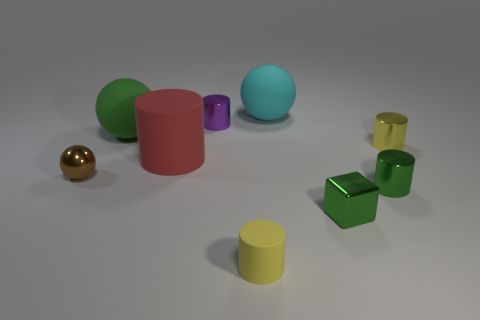Subtract all green spheres. How many spheres are left? 2 Subtract all purple cylinders. How many cylinders are left? 4 Add 6 green blocks. How many green blocks are left? 7 Add 4 big yellow metallic cylinders. How many big yellow metallic cylinders exist? 4 Add 1 big cyan metal objects. How many objects exist? 10 Subtract 0 blue cylinders. How many objects are left? 9 Subtract all balls. How many objects are left? 6 Subtract 2 spheres. How many spheres are left? 1 Subtract all brown spheres. Subtract all red cylinders. How many spheres are left? 2 Subtract all cyan balls. How many blue cylinders are left? 0 